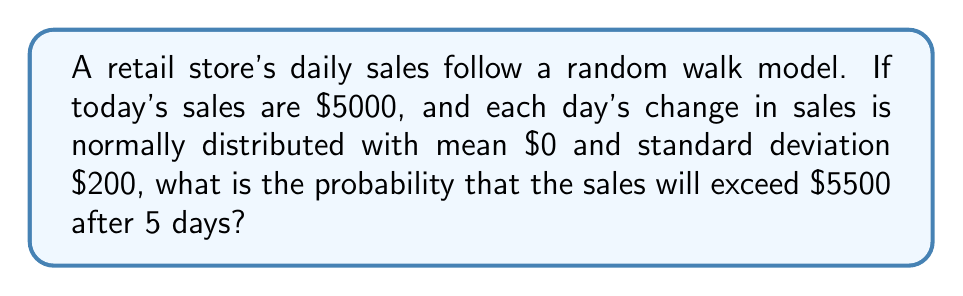Can you solve this math problem? Let's approach this step-by-step:

1) In a random walk model, the changes in sales from day to day are independent and identically distributed.

2) After 5 days, the total change in sales is the sum of 5 independent normal distributions, each with mean $\mu = 0$ and standard deviation $\sigma = 200$.

3) The sum of independent normal distributions is also normally distributed. The mean of the sum is the sum of the means, and the variance of the sum is the sum of the variances.

4) So, after 5 days, the change in sales follows a normal distribution with:
   Mean: $\mu_{total} = 5 \cdot 0 = 0$
   Variance: $\sigma_{total}^2 = 5 \cdot 200^2 = 200,000$
   Standard deviation: $\sigma_{total} = \sqrt{200,000} = 200\sqrt{5}$

5) We want to find the probability that sales exceed $5500. This means the change in sales needs to exceed $500 (since we start at $5000).

6) We can standardize this using the Z-score formula:
   $$Z = \frac{X - \mu}{\sigma} = \frac{500 - 0}{200\sqrt{5}} = \frac{5\sqrt{5}}{2\sqrt{5}} = \frac{5}{2} = 2.5$$

7) We need to find $P(Z > 2.5)$. Using a standard normal table or calculator:
   $P(Z > 2.5) = 1 - P(Z < 2.5) = 1 - 0.9938 = 0.0062$

Therefore, the probability that sales will exceed $5500 after 5 days is approximately 0.0062 or 0.62%.
Answer: 0.0062 